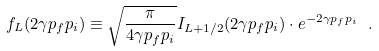Convert formula to latex. <formula><loc_0><loc_0><loc_500><loc_500>f _ { L } ( 2 \gamma p _ { f } p _ { i } ) \equiv \sqrt { \frac { \pi } { 4 \gamma p _ { f } p _ { i } } } I _ { L + 1 / 2 } ( 2 \gamma p _ { f } p _ { i } ) \cdot e ^ { - 2 \gamma p _ { f } p _ { i } } \ .</formula> 